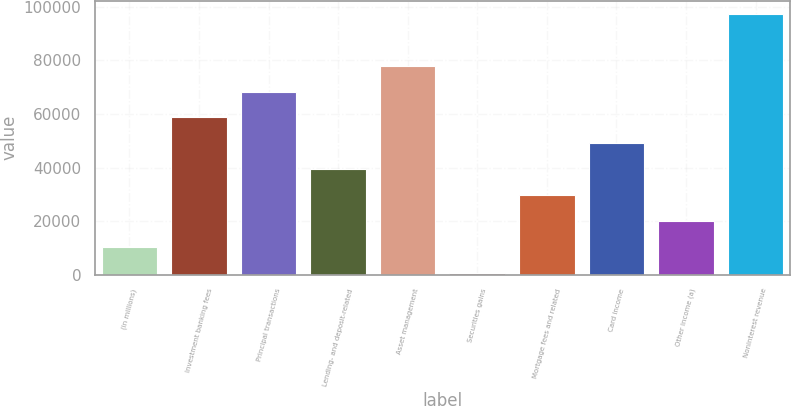Convert chart. <chart><loc_0><loc_0><loc_500><loc_500><bar_chart><fcel>(in millions)<fcel>Investment banking fees<fcel>Principal transactions<fcel>Lending- and deposit-related<fcel>Asset management<fcel>Securities gains<fcel>Mortgage fees and related<fcel>Card income<fcel>Other income (a)<fcel>Noninterest revenue<nl><fcel>10337<fcel>58687<fcel>68357<fcel>39347<fcel>78027<fcel>667<fcel>29677<fcel>49017<fcel>20007<fcel>97367<nl></chart> 